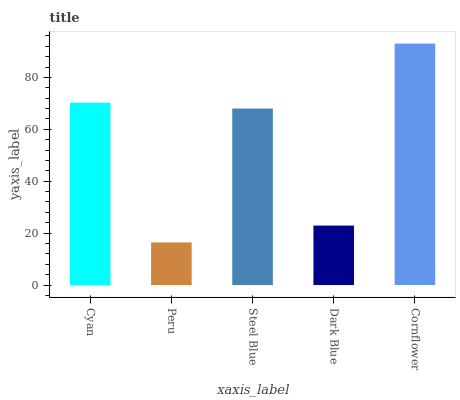Is Peru the minimum?
Answer yes or no. Yes. Is Cornflower the maximum?
Answer yes or no. Yes. Is Steel Blue the minimum?
Answer yes or no. No. Is Steel Blue the maximum?
Answer yes or no. No. Is Steel Blue greater than Peru?
Answer yes or no. Yes. Is Peru less than Steel Blue?
Answer yes or no. Yes. Is Peru greater than Steel Blue?
Answer yes or no. No. Is Steel Blue less than Peru?
Answer yes or no. No. Is Steel Blue the high median?
Answer yes or no. Yes. Is Steel Blue the low median?
Answer yes or no. Yes. Is Cyan the high median?
Answer yes or no. No. Is Cornflower the low median?
Answer yes or no. No. 